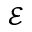Convert formula to latex. <formula><loc_0><loc_0><loc_500><loc_500>\mathcal { E }</formula> 